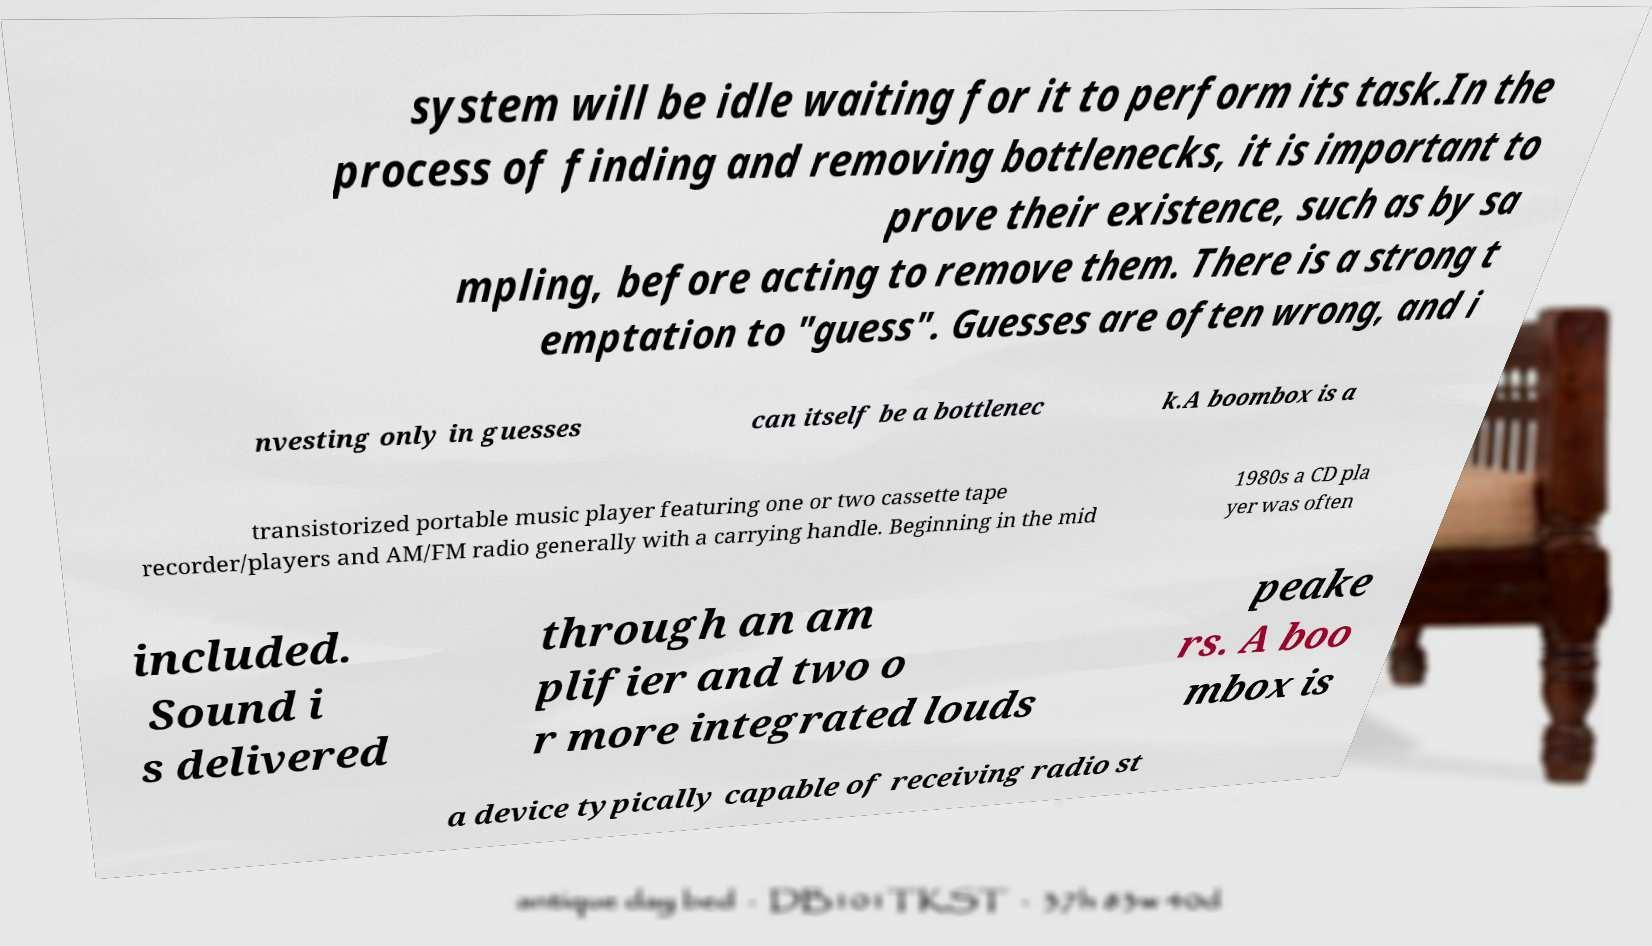Could you assist in decoding the text presented in this image and type it out clearly? system will be idle waiting for it to perform its task.In the process of finding and removing bottlenecks, it is important to prove their existence, such as by sa mpling, before acting to remove them. There is a strong t emptation to "guess". Guesses are often wrong, and i nvesting only in guesses can itself be a bottlenec k.A boombox is a transistorized portable music player featuring one or two cassette tape recorder/players and AM/FM radio generally with a carrying handle. Beginning in the mid 1980s a CD pla yer was often included. Sound i s delivered through an am plifier and two o r more integrated louds peake rs. A boo mbox is a device typically capable of receiving radio st 